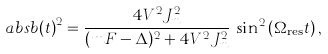Convert formula to latex. <formula><loc_0><loc_0><loc_500><loc_500>\ a b s { b ( t ) } ^ { 2 } = \frac { 4 V ^ { 2 } J _ { m } ^ { 2 } } { ( m F - \Delta ) ^ { 2 } + 4 V ^ { 2 } J _ { m } ^ { 2 } } \, \sin ^ { 2 } \left ( \Omega _ { \text {res} } t \right ) ,</formula> 